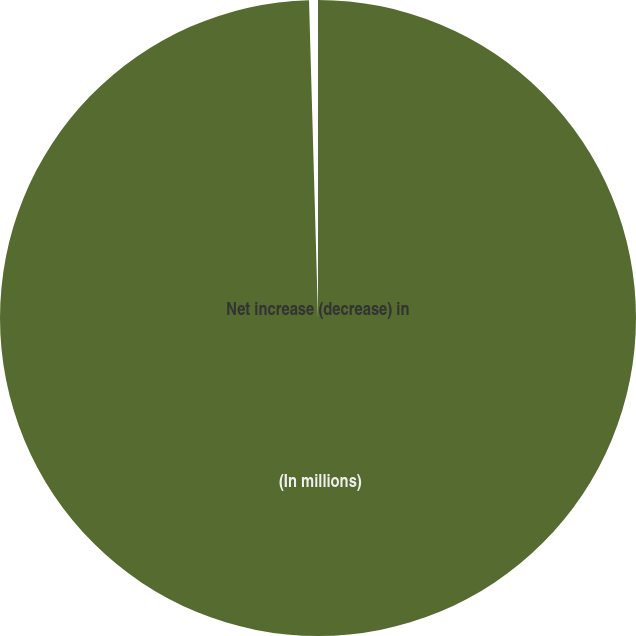Convert chart. <chart><loc_0><loc_0><loc_500><loc_500><pie_chart><fcel>(In millions)<fcel>Net increase (decrease) in<nl><fcel>99.55%<fcel>0.45%<nl></chart> 